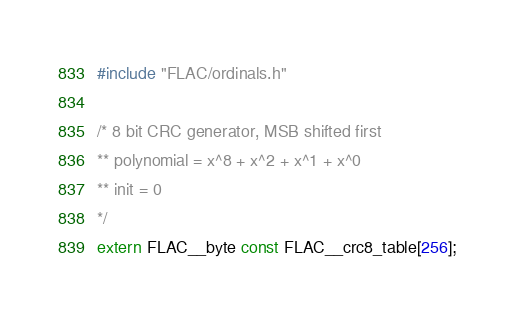Convert code to text. <code><loc_0><loc_0><loc_500><loc_500><_C_>#include "FLAC/ordinals.h"

/* 8 bit CRC generator, MSB shifted first
** polynomial = x^8 + x^2 + x^1 + x^0
** init = 0
*/
extern FLAC__byte const FLAC__crc8_table[256];</code> 